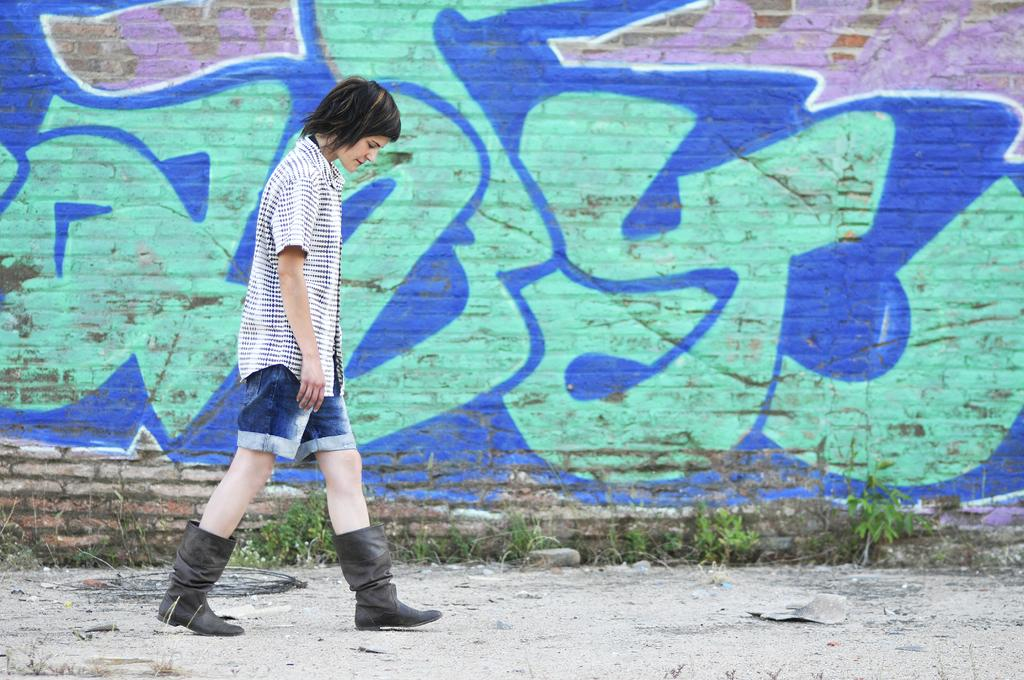What can be seen in the background of the image? There is a wall in the background of the image. What is on the wall? There is a painting on the wall. What type of vegetation is visible in the image? There are tiny plants visible in the image. Who is present in the image? There is a person in the image. What type of footwear is the person wearing? The person is wearing boots. What is the person doing in the image? The person is walking on the floor. Can you see any volcanoes erupting in the image? No, there are no volcanoes or eruptions present in the image. How many rabbits are visible in the image? There are no rabbits present in the image. 